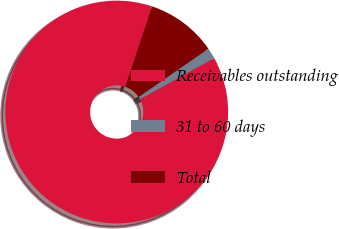Convert chart to OTSL. <chart><loc_0><loc_0><loc_500><loc_500><pie_chart><fcel>Receivables outstanding<fcel>31 to 60 days<fcel>Total<nl><fcel>88.17%<fcel>1.59%<fcel>10.25%<nl></chart> 